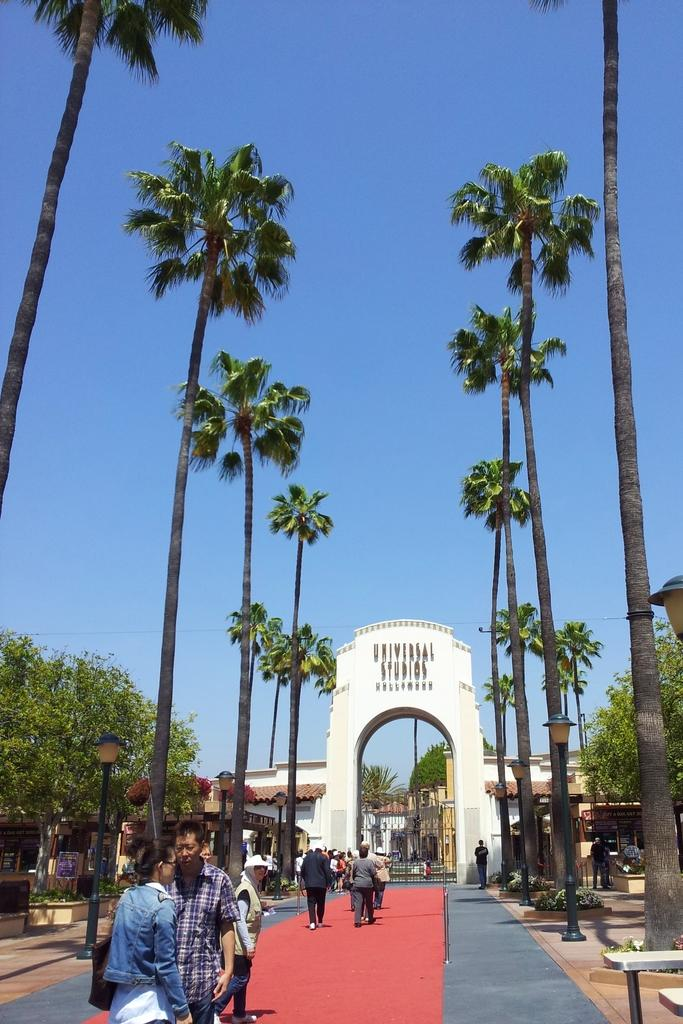What are the people in the image doing? The people in the image are walking on the red carpet. What structure can be seen in the image? There is an arch in the image. What type of background is visible in the image? There are buildings and trees visible in the image. How many bulbs are hanging from the arch in the image? There are no bulbs visible in the image; the focus is on the people walking on the red carpet and the arch itself. 